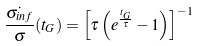<formula> <loc_0><loc_0><loc_500><loc_500>\frac { \dot { \sigma _ { i n f } } } { \sigma } ( t _ { G } ) = \left [ \tau \left ( e ^ { \frac { t _ { G } } { \tau } } - 1 \right ) \right ] ^ { - 1 }</formula> 